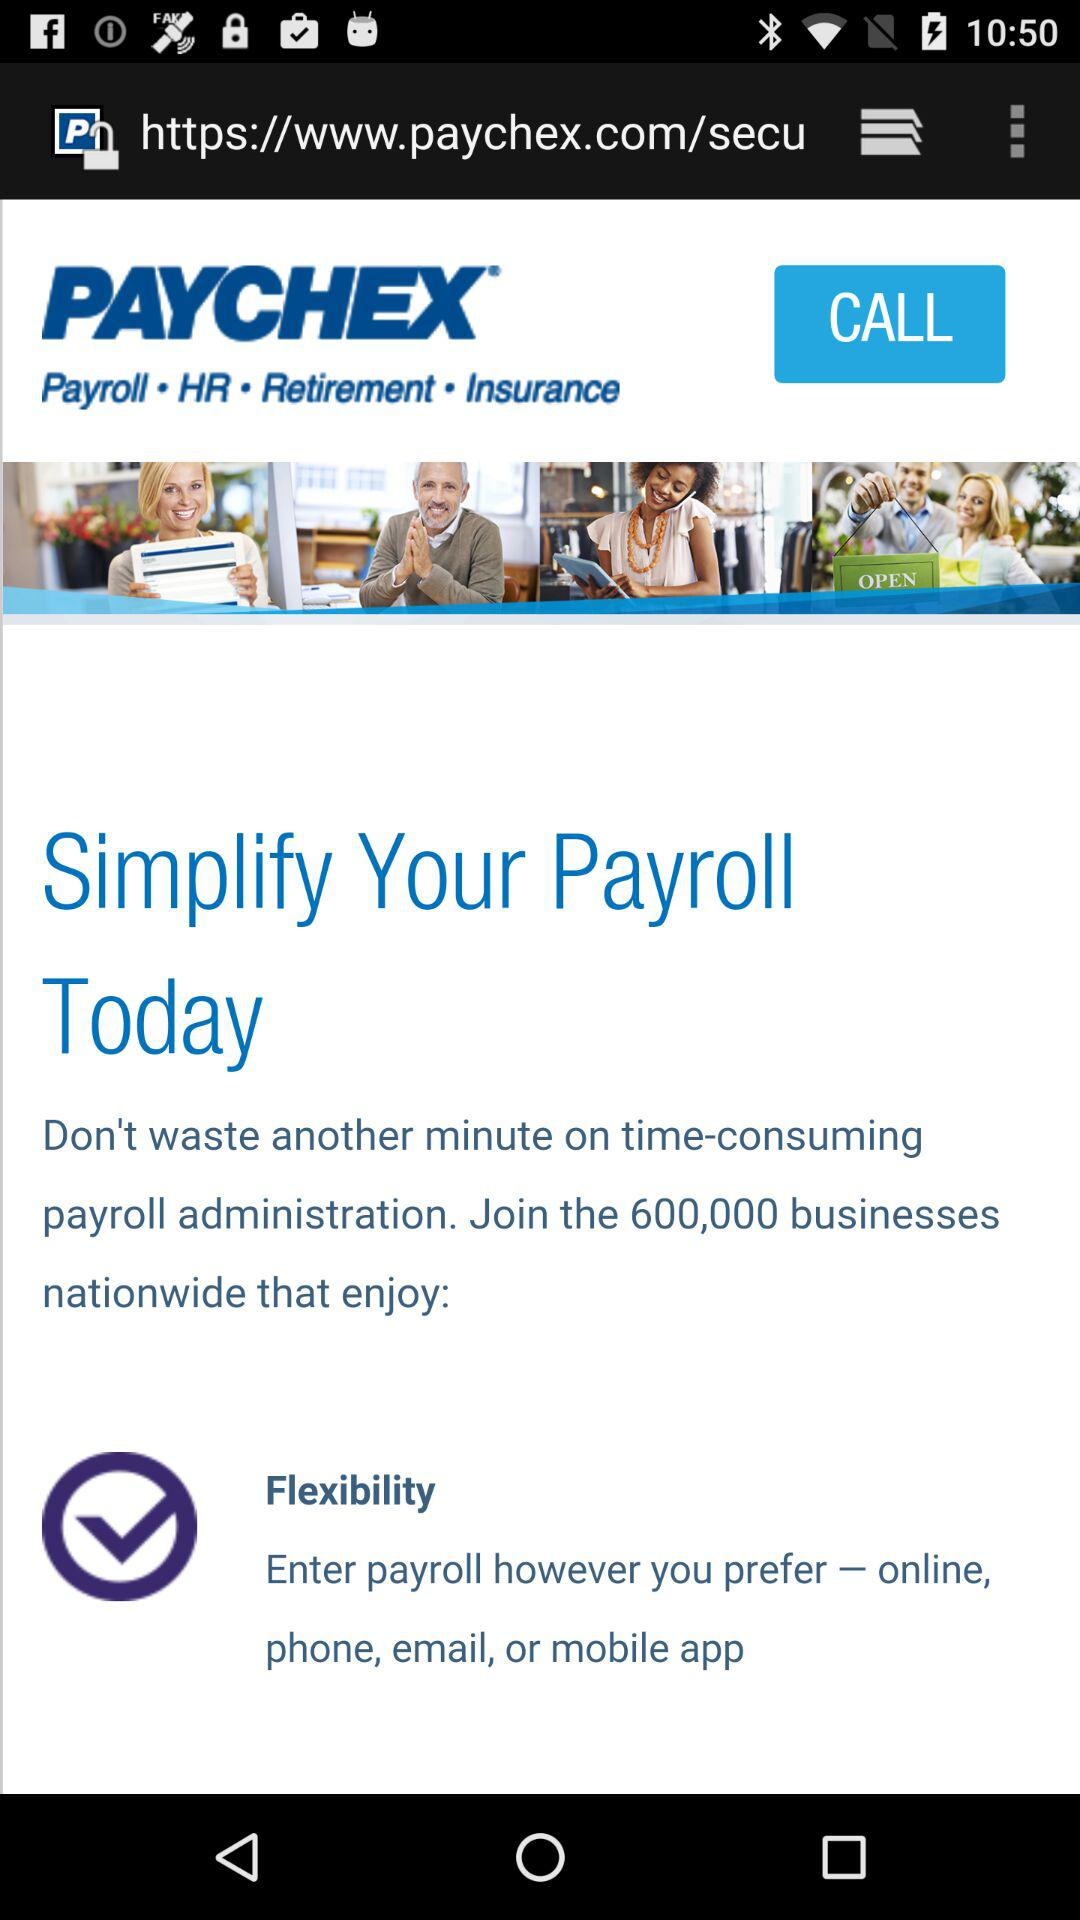What is the name of the application? The name of the application is "PAYCHEX". 